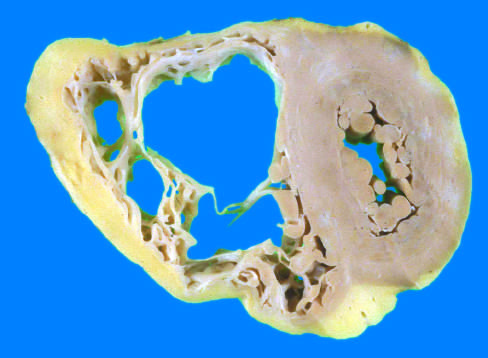what does the left ventricle have in this heart?
Answer the question using a single word or phrase. A grossly normal appearance 